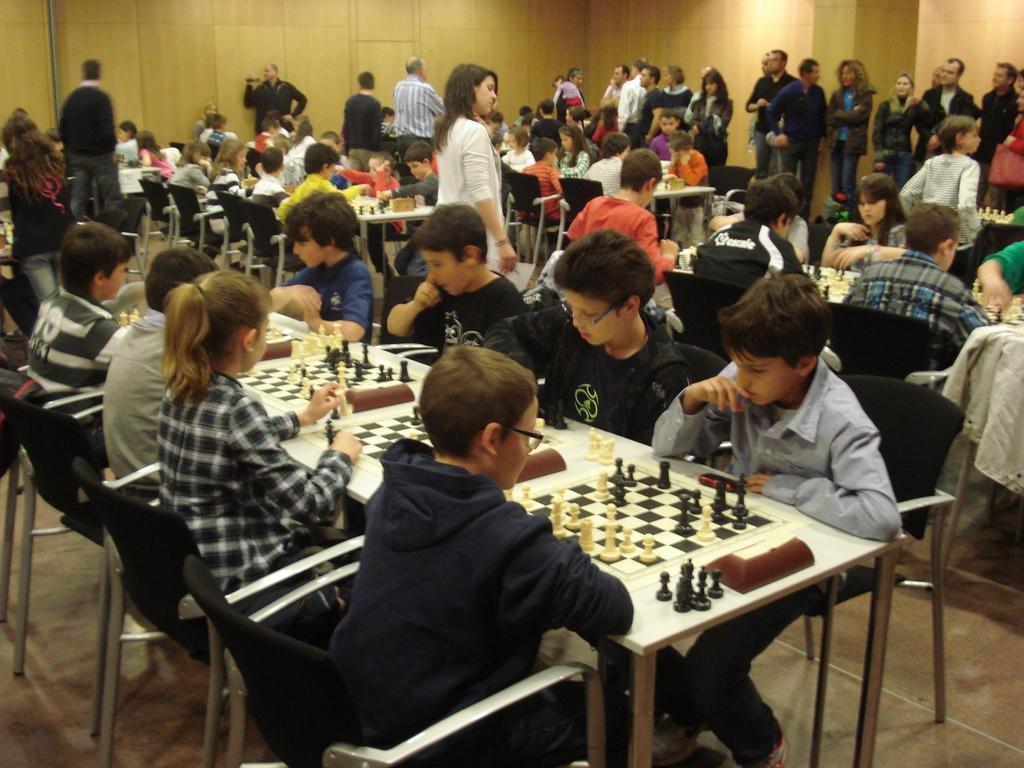Please provide a concise description of this image. in this picture we can see the children sitting on the chair and playing chess game in which chessboard on the table in front of them,here we can see some of the people standing on the corridors.. 